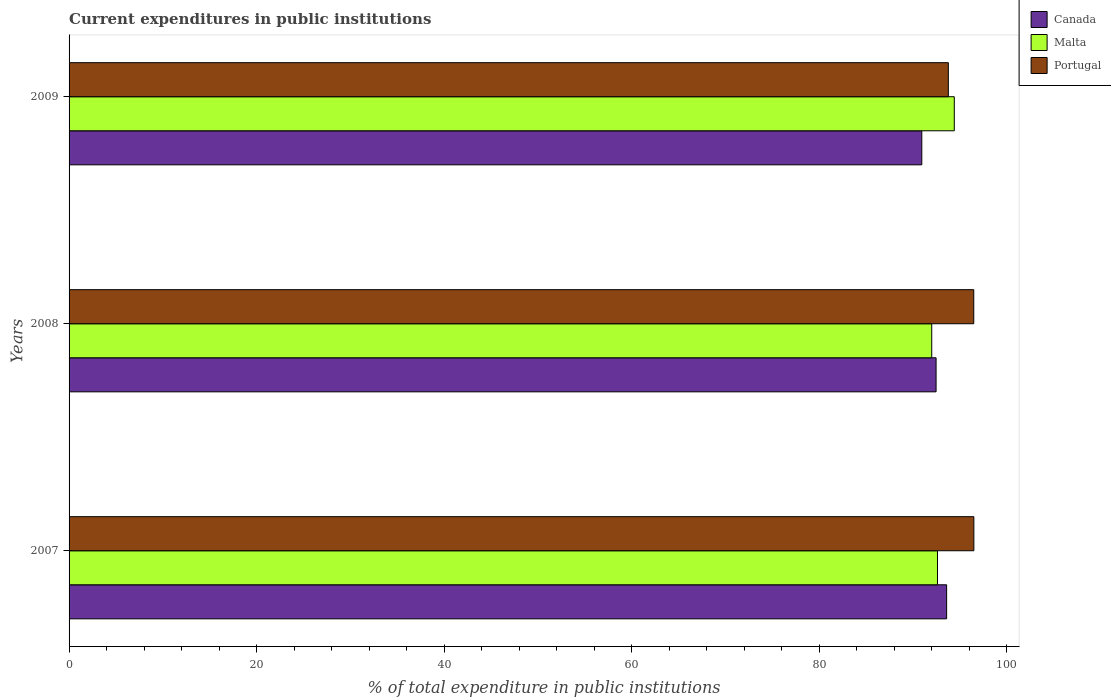How many different coloured bars are there?
Your answer should be compact. 3. How many groups of bars are there?
Your answer should be very brief. 3. Are the number of bars on each tick of the Y-axis equal?
Offer a terse response. Yes. How many bars are there on the 3rd tick from the top?
Offer a terse response. 3. What is the label of the 1st group of bars from the top?
Make the answer very short. 2009. What is the current expenditures in public institutions in Malta in 2007?
Give a very brief answer. 92.6. Across all years, what is the maximum current expenditures in public institutions in Malta?
Provide a succinct answer. 94.39. Across all years, what is the minimum current expenditures in public institutions in Malta?
Keep it short and to the point. 91.99. What is the total current expenditures in public institutions in Malta in the graph?
Your response must be concise. 278.98. What is the difference between the current expenditures in public institutions in Canada in 2007 and that in 2009?
Keep it short and to the point. 2.65. What is the difference between the current expenditures in public institutions in Canada in 2009 and the current expenditures in public institutions in Malta in 2007?
Your answer should be very brief. -1.67. What is the average current expenditures in public institutions in Malta per year?
Ensure brevity in your answer.  92.99. In the year 2007, what is the difference between the current expenditures in public institutions in Malta and current expenditures in public institutions in Portugal?
Your response must be concise. -3.88. In how many years, is the current expenditures in public institutions in Malta greater than 72 %?
Give a very brief answer. 3. What is the ratio of the current expenditures in public institutions in Portugal in 2007 to that in 2009?
Keep it short and to the point. 1.03. What is the difference between the highest and the second highest current expenditures in public institutions in Portugal?
Give a very brief answer. 0.01. What is the difference between the highest and the lowest current expenditures in public institutions in Malta?
Ensure brevity in your answer.  2.41. Is the sum of the current expenditures in public institutions in Canada in 2008 and 2009 greater than the maximum current expenditures in public institutions in Portugal across all years?
Your response must be concise. Yes. What does the 2nd bar from the top in 2009 represents?
Offer a very short reply. Malta. What does the 3rd bar from the bottom in 2007 represents?
Make the answer very short. Portugal. How many bars are there?
Keep it short and to the point. 9. How many years are there in the graph?
Ensure brevity in your answer.  3. What is the difference between two consecutive major ticks on the X-axis?
Your answer should be compact. 20. Does the graph contain any zero values?
Your response must be concise. No. Where does the legend appear in the graph?
Ensure brevity in your answer.  Top right. How are the legend labels stacked?
Your answer should be compact. Vertical. What is the title of the graph?
Keep it short and to the point. Current expenditures in public institutions. What is the label or title of the X-axis?
Give a very brief answer. % of total expenditure in public institutions. What is the label or title of the Y-axis?
Your answer should be compact. Years. What is the % of total expenditure in public institutions in Canada in 2007?
Offer a terse response. 93.57. What is the % of total expenditure in public institutions of Malta in 2007?
Ensure brevity in your answer.  92.6. What is the % of total expenditure in public institutions of Portugal in 2007?
Keep it short and to the point. 96.48. What is the % of total expenditure in public institutions of Canada in 2008?
Ensure brevity in your answer.  92.45. What is the % of total expenditure in public institutions of Malta in 2008?
Your response must be concise. 91.99. What is the % of total expenditure in public institutions of Portugal in 2008?
Your answer should be compact. 96.47. What is the % of total expenditure in public institutions in Canada in 2009?
Your answer should be very brief. 90.93. What is the % of total expenditure in public institutions in Malta in 2009?
Make the answer very short. 94.39. What is the % of total expenditure in public institutions in Portugal in 2009?
Provide a succinct answer. 93.76. Across all years, what is the maximum % of total expenditure in public institutions in Canada?
Keep it short and to the point. 93.57. Across all years, what is the maximum % of total expenditure in public institutions in Malta?
Ensure brevity in your answer.  94.39. Across all years, what is the maximum % of total expenditure in public institutions in Portugal?
Offer a very short reply. 96.48. Across all years, what is the minimum % of total expenditure in public institutions of Canada?
Provide a succinct answer. 90.93. Across all years, what is the minimum % of total expenditure in public institutions in Malta?
Provide a short and direct response. 91.99. Across all years, what is the minimum % of total expenditure in public institutions of Portugal?
Keep it short and to the point. 93.76. What is the total % of total expenditure in public institutions in Canada in the graph?
Your response must be concise. 276.95. What is the total % of total expenditure in public institutions in Malta in the graph?
Provide a succinct answer. 278.98. What is the total % of total expenditure in public institutions in Portugal in the graph?
Your answer should be compact. 286.7. What is the difference between the % of total expenditure in public institutions of Canada in 2007 and that in 2008?
Offer a very short reply. 1.12. What is the difference between the % of total expenditure in public institutions of Malta in 2007 and that in 2008?
Provide a short and direct response. 0.61. What is the difference between the % of total expenditure in public institutions of Portugal in 2007 and that in 2008?
Offer a terse response. 0.01. What is the difference between the % of total expenditure in public institutions of Canada in 2007 and that in 2009?
Keep it short and to the point. 2.65. What is the difference between the % of total expenditure in public institutions in Malta in 2007 and that in 2009?
Provide a short and direct response. -1.79. What is the difference between the % of total expenditure in public institutions of Portugal in 2007 and that in 2009?
Offer a terse response. 2.72. What is the difference between the % of total expenditure in public institutions in Canada in 2008 and that in 2009?
Provide a short and direct response. 1.52. What is the difference between the % of total expenditure in public institutions of Malta in 2008 and that in 2009?
Your response must be concise. -2.41. What is the difference between the % of total expenditure in public institutions in Portugal in 2008 and that in 2009?
Offer a very short reply. 2.71. What is the difference between the % of total expenditure in public institutions of Canada in 2007 and the % of total expenditure in public institutions of Malta in 2008?
Offer a very short reply. 1.59. What is the difference between the % of total expenditure in public institutions of Canada in 2007 and the % of total expenditure in public institutions of Portugal in 2008?
Offer a terse response. -2.89. What is the difference between the % of total expenditure in public institutions of Malta in 2007 and the % of total expenditure in public institutions of Portugal in 2008?
Your answer should be compact. -3.87. What is the difference between the % of total expenditure in public institutions of Canada in 2007 and the % of total expenditure in public institutions of Malta in 2009?
Your response must be concise. -0.82. What is the difference between the % of total expenditure in public institutions in Canada in 2007 and the % of total expenditure in public institutions in Portugal in 2009?
Your answer should be compact. -0.18. What is the difference between the % of total expenditure in public institutions of Malta in 2007 and the % of total expenditure in public institutions of Portugal in 2009?
Your answer should be very brief. -1.16. What is the difference between the % of total expenditure in public institutions in Canada in 2008 and the % of total expenditure in public institutions in Malta in 2009?
Offer a terse response. -1.94. What is the difference between the % of total expenditure in public institutions of Canada in 2008 and the % of total expenditure in public institutions of Portugal in 2009?
Offer a very short reply. -1.31. What is the difference between the % of total expenditure in public institutions of Malta in 2008 and the % of total expenditure in public institutions of Portugal in 2009?
Your answer should be compact. -1.77. What is the average % of total expenditure in public institutions in Canada per year?
Your answer should be very brief. 92.32. What is the average % of total expenditure in public institutions in Malta per year?
Provide a succinct answer. 92.99. What is the average % of total expenditure in public institutions of Portugal per year?
Provide a succinct answer. 95.57. In the year 2007, what is the difference between the % of total expenditure in public institutions of Canada and % of total expenditure in public institutions of Malta?
Your response must be concise. 0.97. In the year 2007, what is the difference between the % of total expenditure in public institutions of Canada and % of total expenditure in public institutions of Portugal?
Give a very brief answer. -2.9. In the year 2007, what is the difference between the % of total expenditure in public institutions in Malta and % of total expenditure in public institutions in Portugal?
Give a very brief answer. -3.88. In the year 2008, what is the difference between the % of total expenditure in public institutions of Canada and % of total expenditure in public institutions of Malta?
Your response must be concise. 0.46. In the year 2008, what is the difference between the % of total expenditure in public institutions in Canada and % of total expenditure in public institutions in Portugal?
Ensure brevity in your answer.  -4.02. In the year 2008, what is the difference between the % of total expenditure in public institutions in Malta and % of total expenditure in public institutions in Portugal?
Ensure brevity in your answer.  -4.48. In the year 2009, what is the difference between the % of total expenditure in public institutions in Canada and % of total expenditure in public institutions in Malta?
Provide a succinct answer. -3.47. In the year 2009, what is the difference between the % of total expenditure in public institutions of Canada and % of total expenditure in public institutions of Portugal?
Provide a succinct answer. -2.83. In the year 2009, what is the difference between the % of total expenditure in public institutions of Malta and % of total expenditure in public institutions of Portugal?
Your response must be concise. 0.64. What is the ratio of the % of total expenditure in public institutions of Canada in 2007 to that in 2008?
Your response must be concise. 1.01. What is the ratio of the % of total expenditure in public institutions of Malta in 2007 to that in 2008?
Provide a succinct answer. 1.01. What is the ratio of the % of total expenditure in public institutions of Canada in 2007 to that in 2009?
Offer a terse response. 1.03. What is the ratio of the % of total expenditure in public institutions in Malta in 2007 to that in 2009?
Your response must be concise. 0.98. What is the ratio of the % of total expenditure in public institutions in Canada in 2008 to that in 2009?
Your answer should be very brief. 1.02. What is the ratio of the % of total expenditure in public institutions of Malta in 2008 to that in 2009?
Provide a succinct answer. 0.97. What is the ratio of the % of total expenditure in public institutions in Portugal in 2008 to that in 2009?
Your answer should be compact. 1.03. What is the difference between the highest and the second highest % of total expenditure in public institutions in Canada?
Your answer should be very brief. 1.12. What is the difference between the highest and the second highest % of total expenditure in public institutions in Malta?
Offer a terse response. 1.79. What is the difference between the highest and the second highest % of total expenditure in public institutions in Portugal?
Offer a very short reply. 0.01. What is the difference between the highest and the lowest % of total expenditure in public institutions in Canada?
Make the answer very short. 2.65. What is the difference between the highest and the lowest % of total expenditure in public institutions in Malta?
Keep it short and to the point. 2.41. What is the difference between the highest and the lowest % of total expenditure in public institutions of Portugal?
Ensure brevity in your answer.  2.72. 